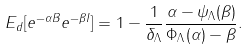Convert formula to latex. <formula><loc_0><loc_0><loc_500><loc_500>E _ { d } [ e ^ { - \alpha B } e ^ { - \beta I } ] = 1 - \frac { 1 } { \delta _ { \Lambda } } \frac { \alpha - \psi _ { \Lambda } ( \beta ) } { \Phi _ { \Lambda } ( \alpha ) - \beta } .</formula> 